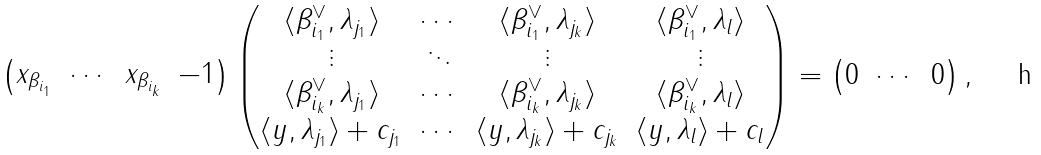<formula> <loc_0><loc_0><loc_500><loc_500>\begin{pmatrix} x _ { \beta _ { i _ { 1 } } } & \cdots & x _ { \beta _ { i _ { k } } } & - 1 \end{pmatrix} \begin{pmatrix} \langle \beta _ { i _ { 1 } } ^ { \vee } , \lambda _ { j _ { 1 } } \rangle & \cdots & \langle \beta _ { i _ { 1 } } ^ { \vee } , \lambda _ { j _ { k } } \rangle & \langle \beta _ { i _ { 1 } } ^ { \vee } , \lambda _ { l } \rangle \\ \vdots & \ddots & \vdots & \vdots \\ \langle \beta _ { i _ { k } } ^ { \vee } , \lambda _ { j _ { 1 } } \rangle & \cdots & \langle \beta _ { i _ { k } } ^ { \vee } , \lambda _ { j _ { k } } \rangle & \langle \beta _ { i _ { k } } ^ { \vee } , \lambda _ { l } \rangle \\ \langle y , \lambda _ { j _ { 1 } } \rangle + c _ { j _ { 1 } } & \cdots & \langle y , \lambda _ { j _ { k } } \rangle + c _ { j _ { k } } & \langle y , \lambda _ { l } \rangle + c _ { l } \end{pmatrix} = \begin{pmatrix} 0 & \cdots & 0 \end{pmatrix} ,</formula> 